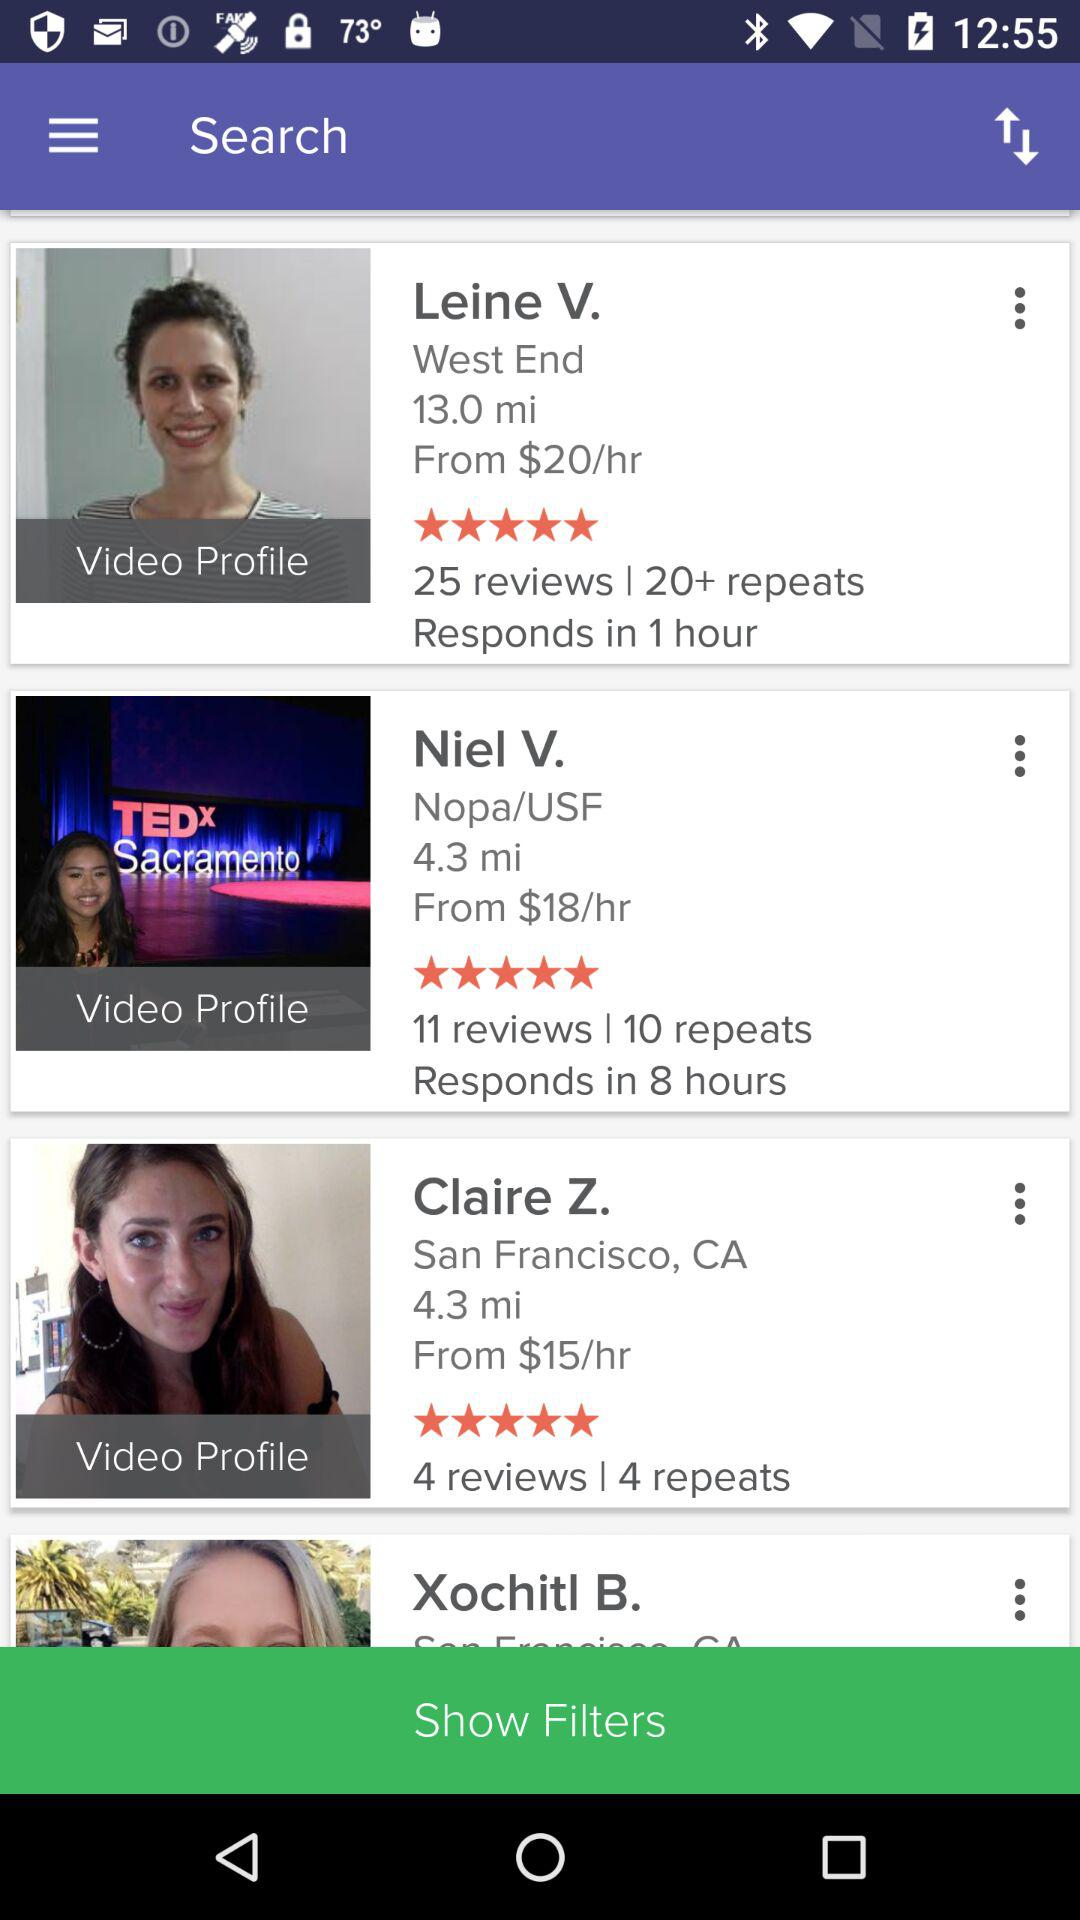What is the number of repeats for Niel V.? The number of repeats for Niel V. is 10. 